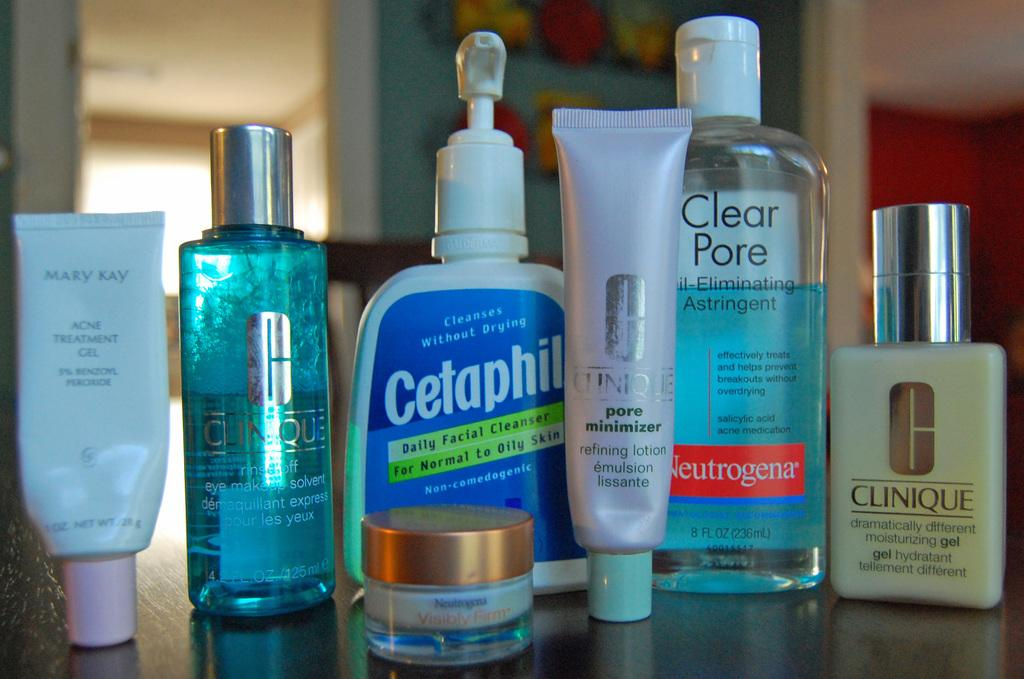<image>
Render a clear and concise summary of the photo. A collection of toiletry products including Cetaphil and Clear Pore. 